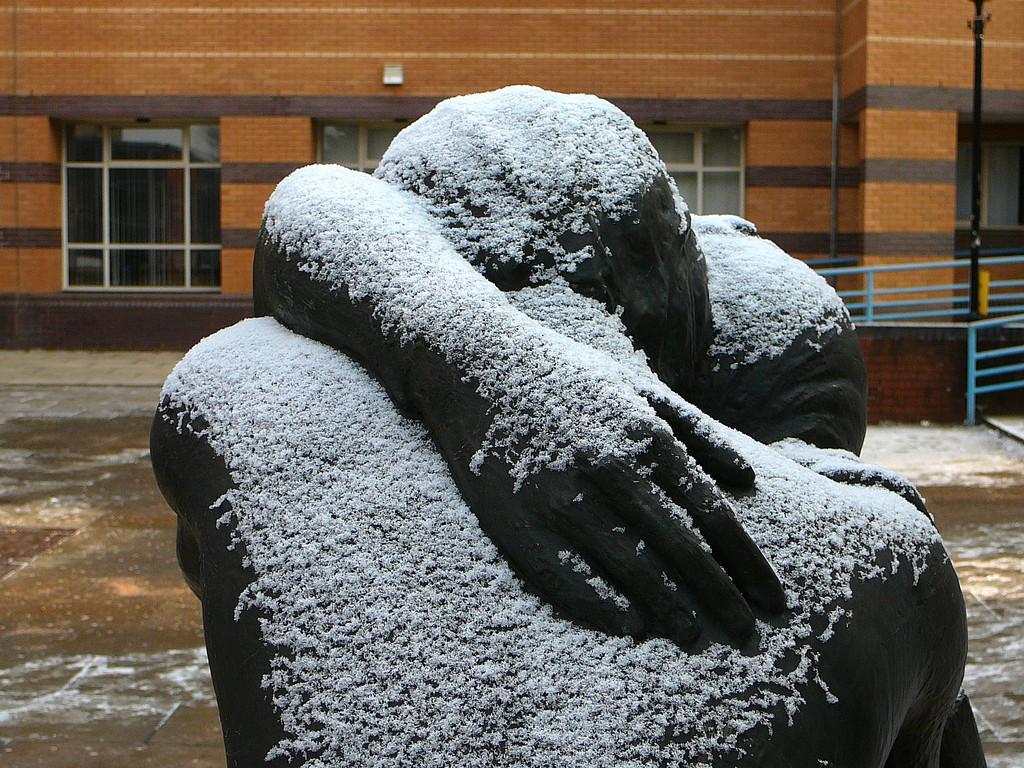Describe this image in one or two sentences. In this image there is a sculpture, in the background there is a building, to that building there are windows, on the left side there is a fencing. 